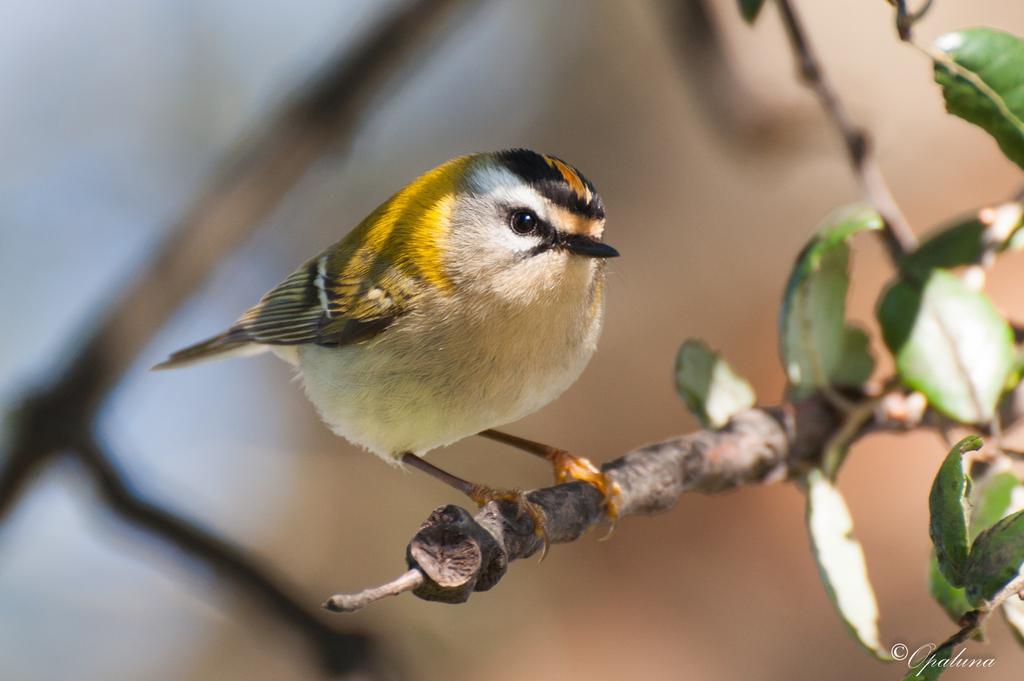Could you give a brief overview of what you see in this image? In this picture, we see a bird in black and yellow color is on the branch of the plant. On the right side of the picture, we see a tree or a plant. 